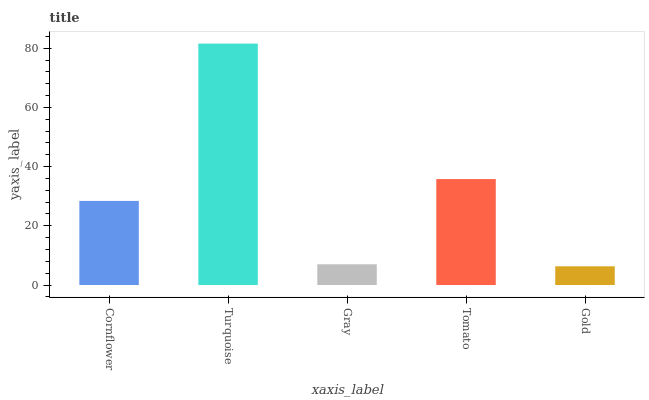Is Gold the minimum?
Answer yes or no. Yes. Is Turquoise the maximum?
Answer yes or no. Yes. Is Gray the minimum?
Answer yes or no. No. Is Gray the maximum?
Answer yes or no. No. Is Turquoise greater than Gray?
Answer yes or no. Yes. Is Gray less than Turquoise?
Answer yes or no. Yes. Is Gray greater than Turquoise?
Answer yes or no. No. Is Turquoise less than Gray?
Answer yes or no. No. Is Cornflower the high median?
Answer yes or no. Yes. Is Cornflower the low median?
Answer yes or no. Yes. Is Tomato the high median?
Answer yes or no. No. Is Turquoise the low median?
Answer yes or no. No. 